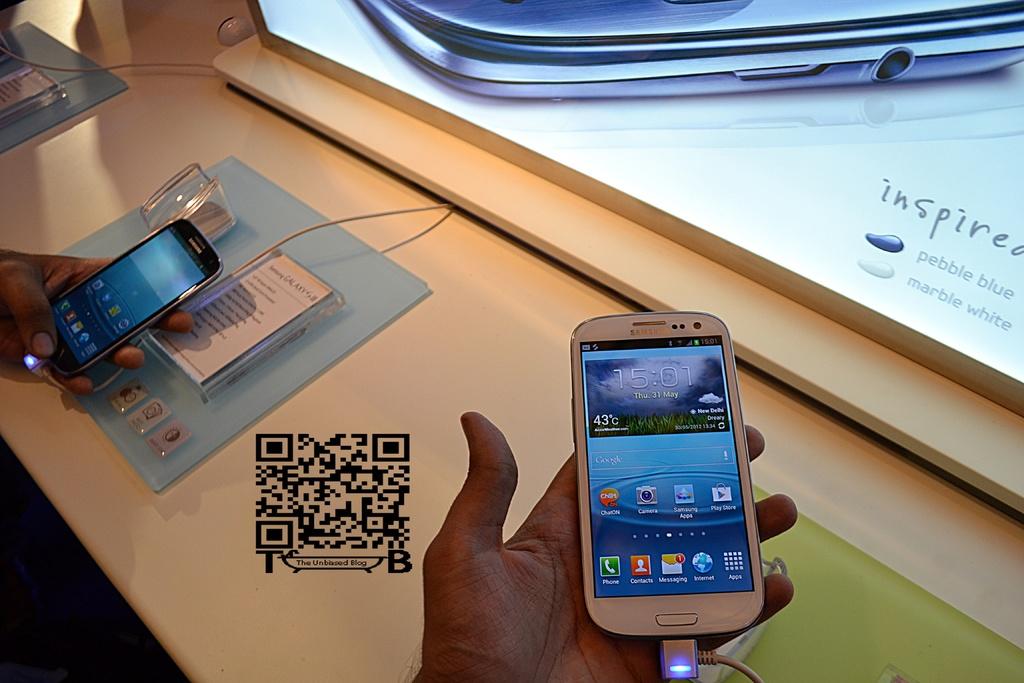What is the brand of the white phone?
Give a very brief answer. Samsung. What time is on display?
Your answer should be very brief. 15:01. 